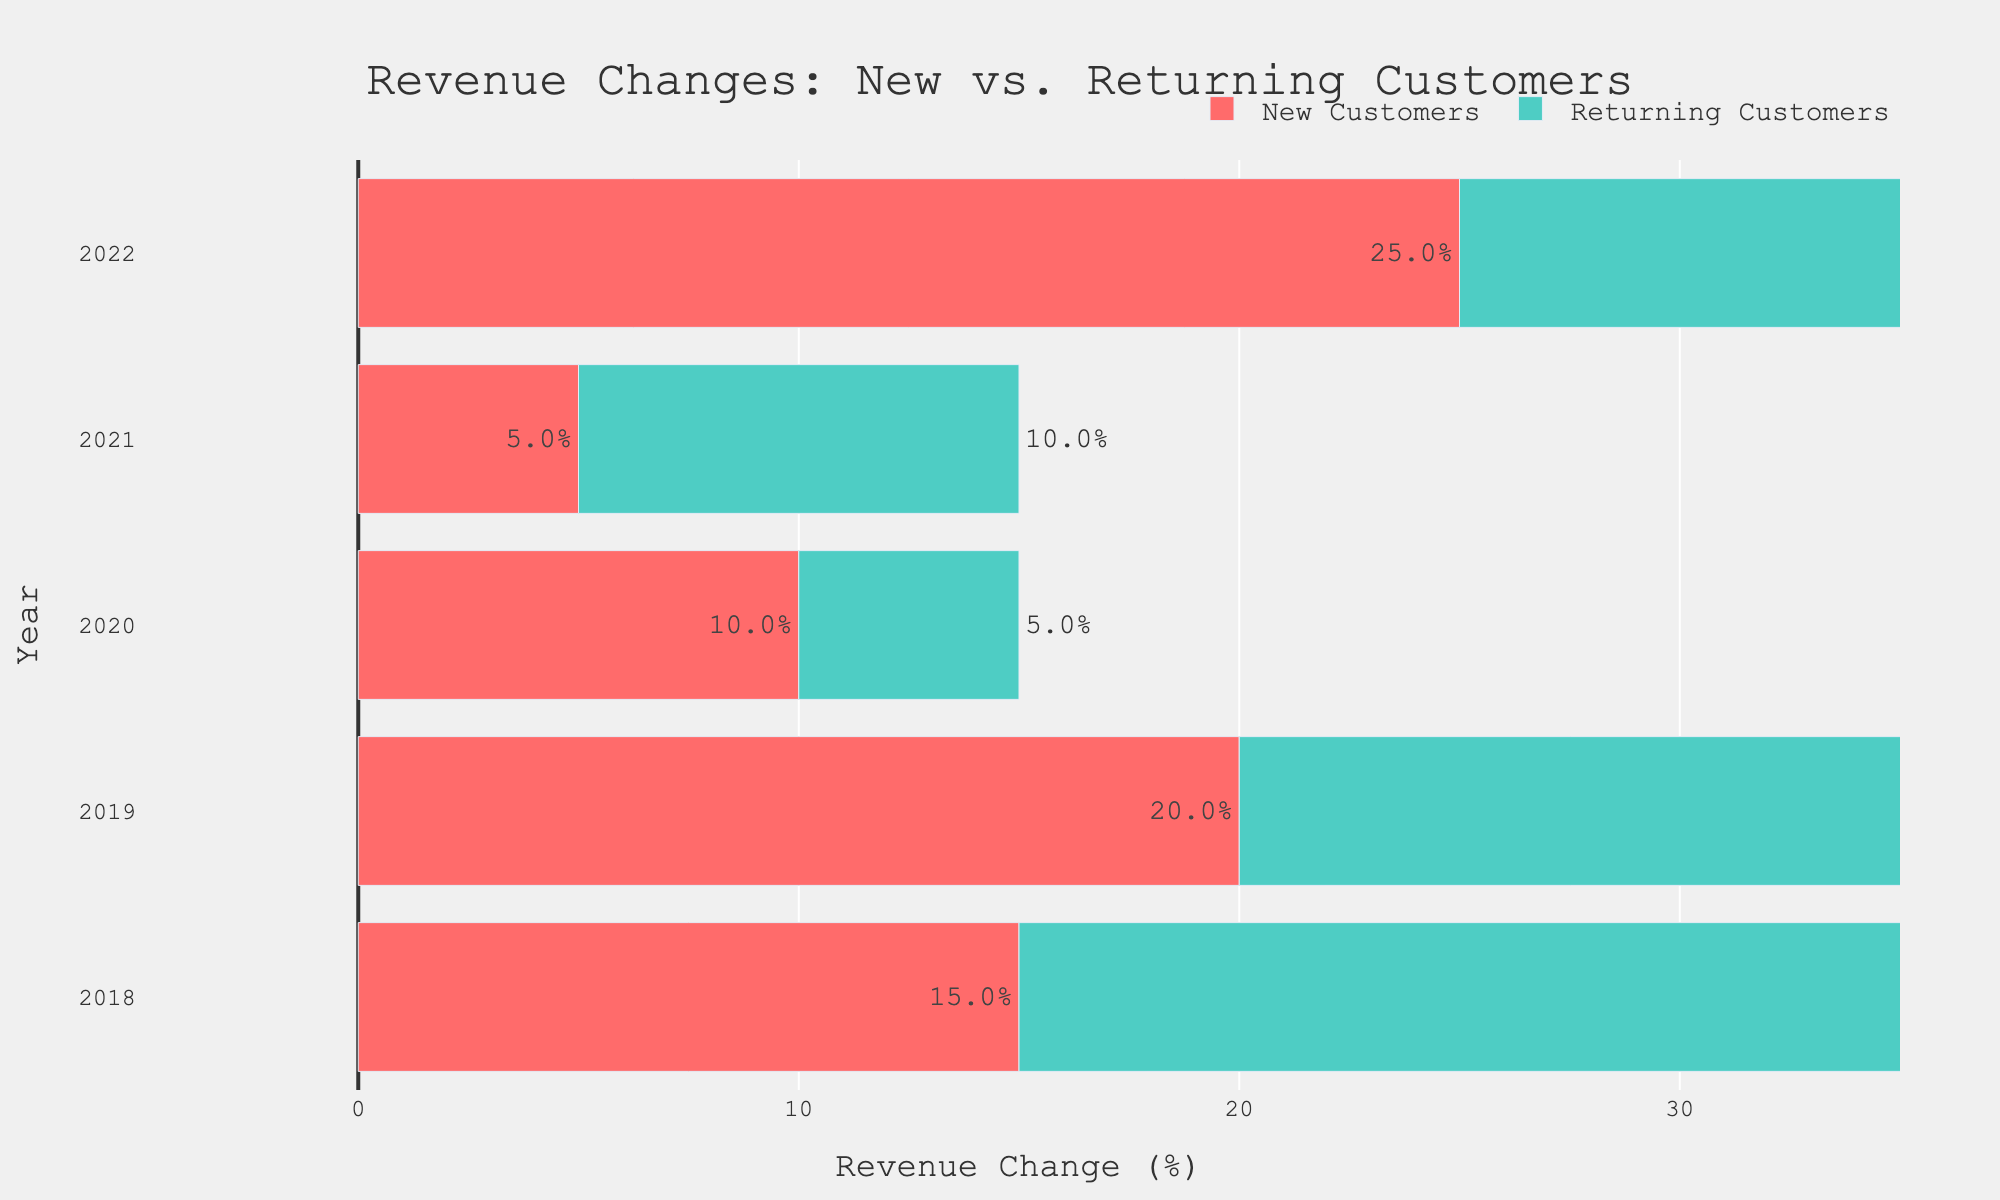What's the overall percentage change in revenue for both new and returning customers from 2018 to 2022? To calculate the overall percentage change, sum the percentage changes for each year for new and returning customers separately and then add them up. For new customers: 15 + 20 + 10 + 5 + 25 = 75. For returning customers: 25 + 30 + 5 + 10 + 15 = 85. Add the two sums: 75 + 85 = 160
Answer: 160 In which year did new customers show the highest percentage revenue change? Look at the bars representing new customers for each year and identify the year with the longest bar. In 2022, the bar for new customers shows a 25% revenue change, which is the highest.
Answer: 2022 How does the average revenue change for returning customers compare to new customers over the five years? Calculate the average change for both new and returning customers. For new customers: (15 + 20 + 10 + 5 + 25) / 5 = 15. For returning customers: (25 + 30 + 5 + 10 + 15) / 5 = 17. The returning customers have a higher average revenue change compared to new customers.
Answer: Returning customers What's the difference in revenue change between new and returning customers in 2019? Subtract the revenue change for new customers from that of returning customers in 2019. The values are 30% for returning customers and 20% for new customers, so 30 - 20 = 10%.
Answer: 10% Which customer type showed a decreasing trend in revenue change from 2018 to 2021? Analyze the trend of each customer type by observing the changes in the lengths of the bars for each year from 2018 to 2021. The bars for new customers decrease from 15% in 2018 to 5% in 2021, indicating a decreasing trend.
Answer: New customers What was the combined revenue change in 2020 for both customer types? Add the percentage changes for both customer types in 2020. New customers had a 10% change, and returning customers had a 5% change, so 10 + 5 = 15%.
Answer: 15% Between which two consecutive years did returning customers see the largest drop in revenue change? Compare the differences in revenue changes for returning customers between each pair of consecutive years. The biggest drop is between 2019 (30%) and 2020 (5%), which is a difference of 25%.
Answer: 2019 and 2020 How much higher was the revenue change for returning customers compared to new customers in 2018? Subtract the revenue change for new customers from that of returning customers for 2018. The values are 25% for returning customers and 15% for new customers, so 25 - 15 = 10%.
Answer: 10% What's the most significant change observed for new customers between any two years? Find the year-to-year differences in the revenue change for new customers and identify the largest one. The most significant change is from 2021 (5%) to 2022 (25%), which is an increase of 20%.
Answer: 20% Did returning customers have any year where their revenue change was equal to that of new customers? Compare the revenue change values for new and returning customers in each year. In 2021, both customer types had an equal revenue change of 10%.
Answer: Yes, in 2021 